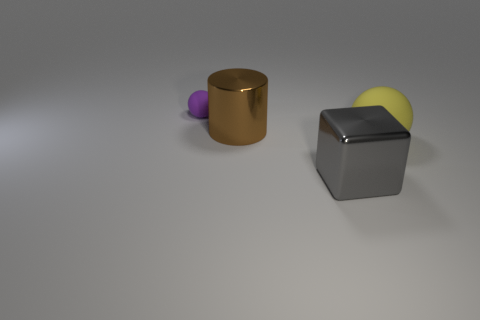There is a big object behind the sphere to the right of the purple ball; what is it made of?
Offer a very short reply. Metal. Are there an equal number of big yellow balls to the right of the yellow sphere and purple cubes?
Give a very brief answer. Yes. Are there any other things that are the same material as the tiny purple thing?
Provide a short and direct response. Yes. Do the metallic object behind the big yellow ball and the ball left of the brown object have the same color?
Provide a succinct answer. No. What number of matte spheres are both to the left of the big gray metal block and on the right side of the tiny matte object?
Make the answer very short. 0. How many other objects are there of the same shape as the big yellow matte thing?
Ensure brevity in your answer.  1. Are there more large yellow objects that are behind the big brown shiny thing than shiny cubes?
Keep it short and to the point. No. There is a large thing behind the big yellow rubber sphere; what color is it?
Make the answer very short. Brown. How many metal objects are blocks or brown objects?
Give a very brief answer. 2. Are there any large gray metal objects that are behind the matte object behind the rubber sphere in front of the small purple matte object?
Offer a very short reply. No. 